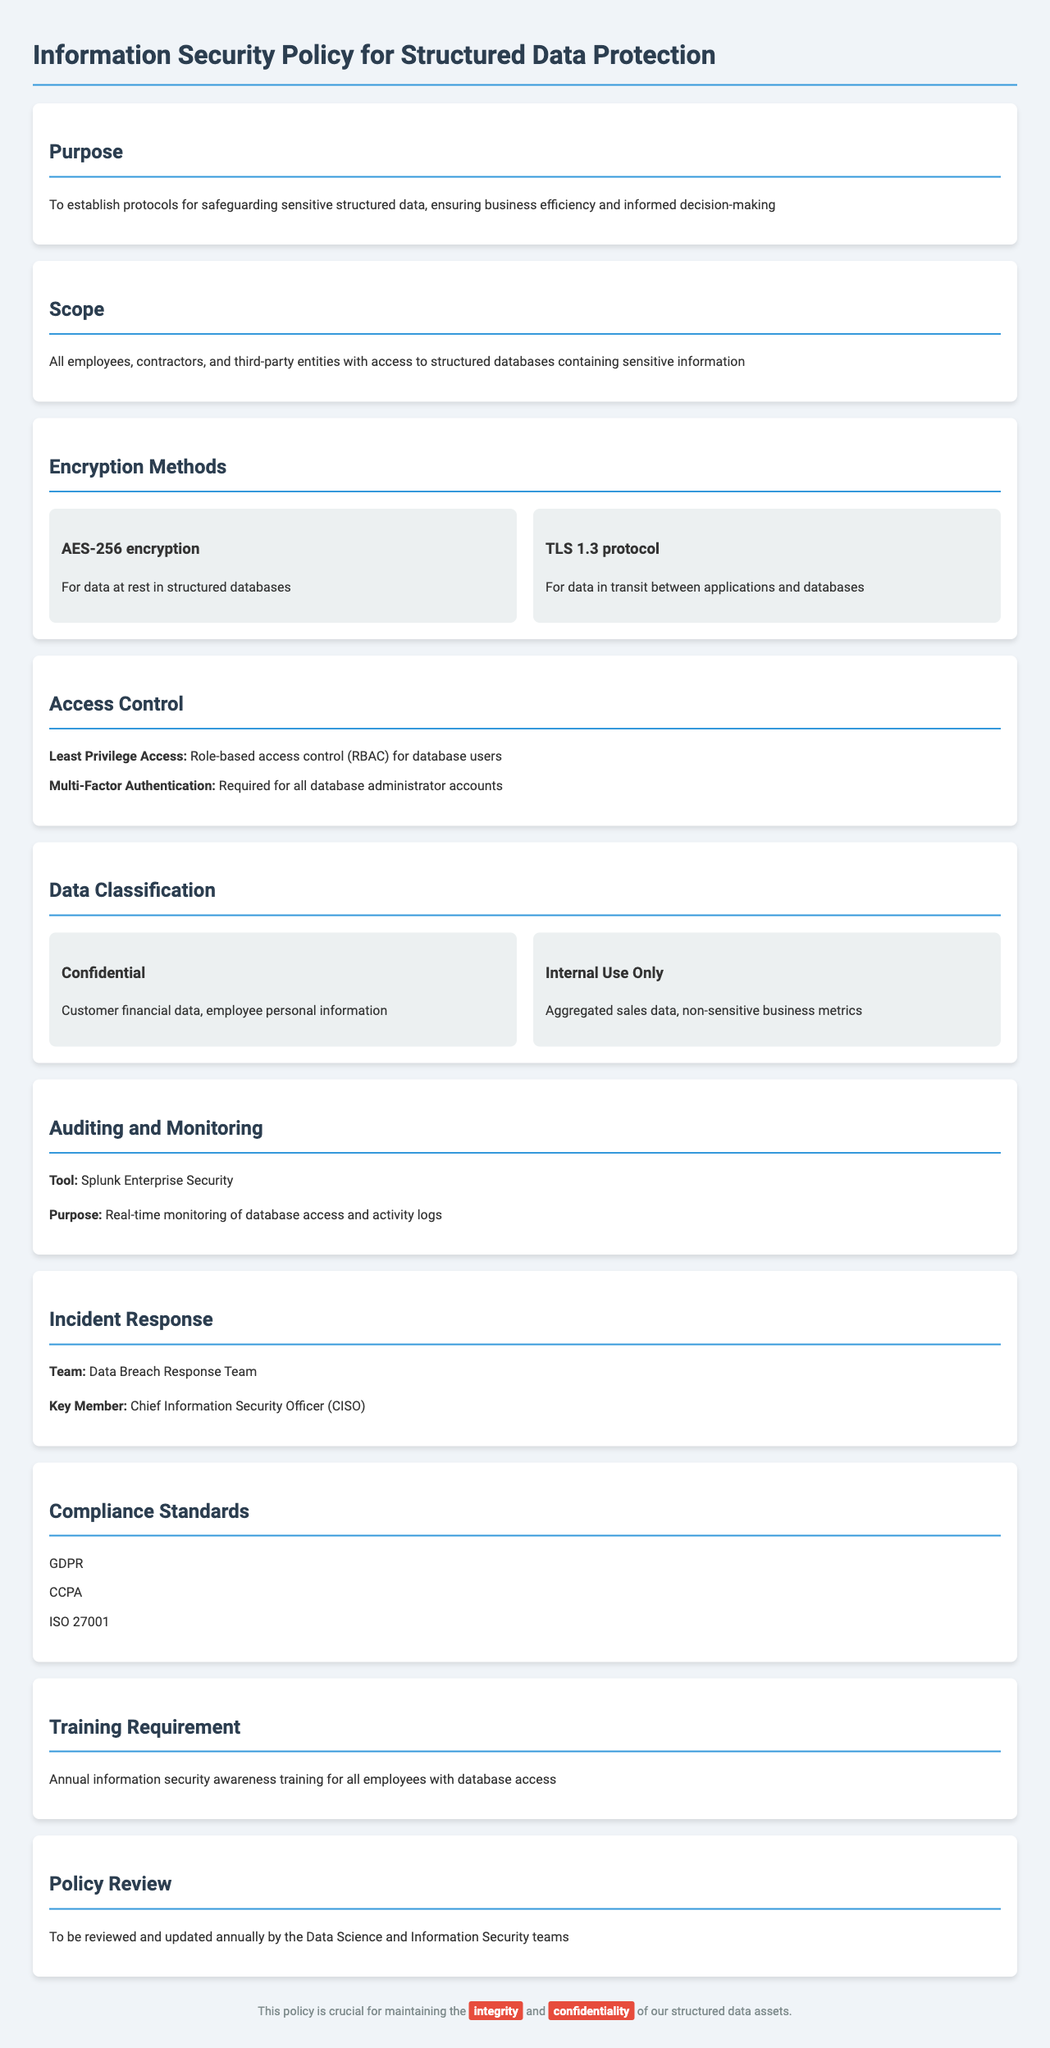What is the purpose of the policy? The purpose is to establish protocols for safeguarding sensitive structured data, ensuring business efficiency and informed decision-making.
Answer: To establish protocols for safeguarding sensitive structured data, ensuring business efficiency and informed decision-making Who is responsible for the incident response team? The incident response team key member is specified in the document.
Answer: Chief Information Security Officer (CISO) What encryption method is used for data at rest? The document specifies which encryption methods are applied to data at rest.
Answer: AES-256 encryption What type of access control is required for database administrator accounts? The policy details a specific requirement for access control regarding database administrators.
Answer: Multi-Factor Authentication Which compliance standard is mentioned in the document? The document lists compliance standards that must be adhered to.
Answer: GDPR What is required annually for employees with database access? The document specifies training requirements for employees with database access.
Answer: Annual information security awareness training What is the tool mentioned for auditing and monitoring? The document identifies a specific tool used for monitoring database access and activity logs.
Answer: Splunk Enterprise Security What constitutes confidential data as per the policy? The document defines what is classified as confidential data.
Answer: Customer financial data, employee personal information How often is the policy reviewed? The document indicates the frequency of the policy review process.
Answer: Annually 